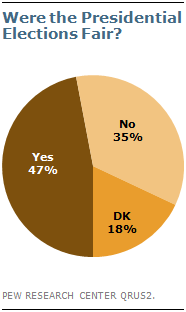Outline some significant characteristics in this image. What corresponds to a value of 0.47... is not clear. The number 1.34 is significantly larger than the number 0, which is the value of 'no.' 